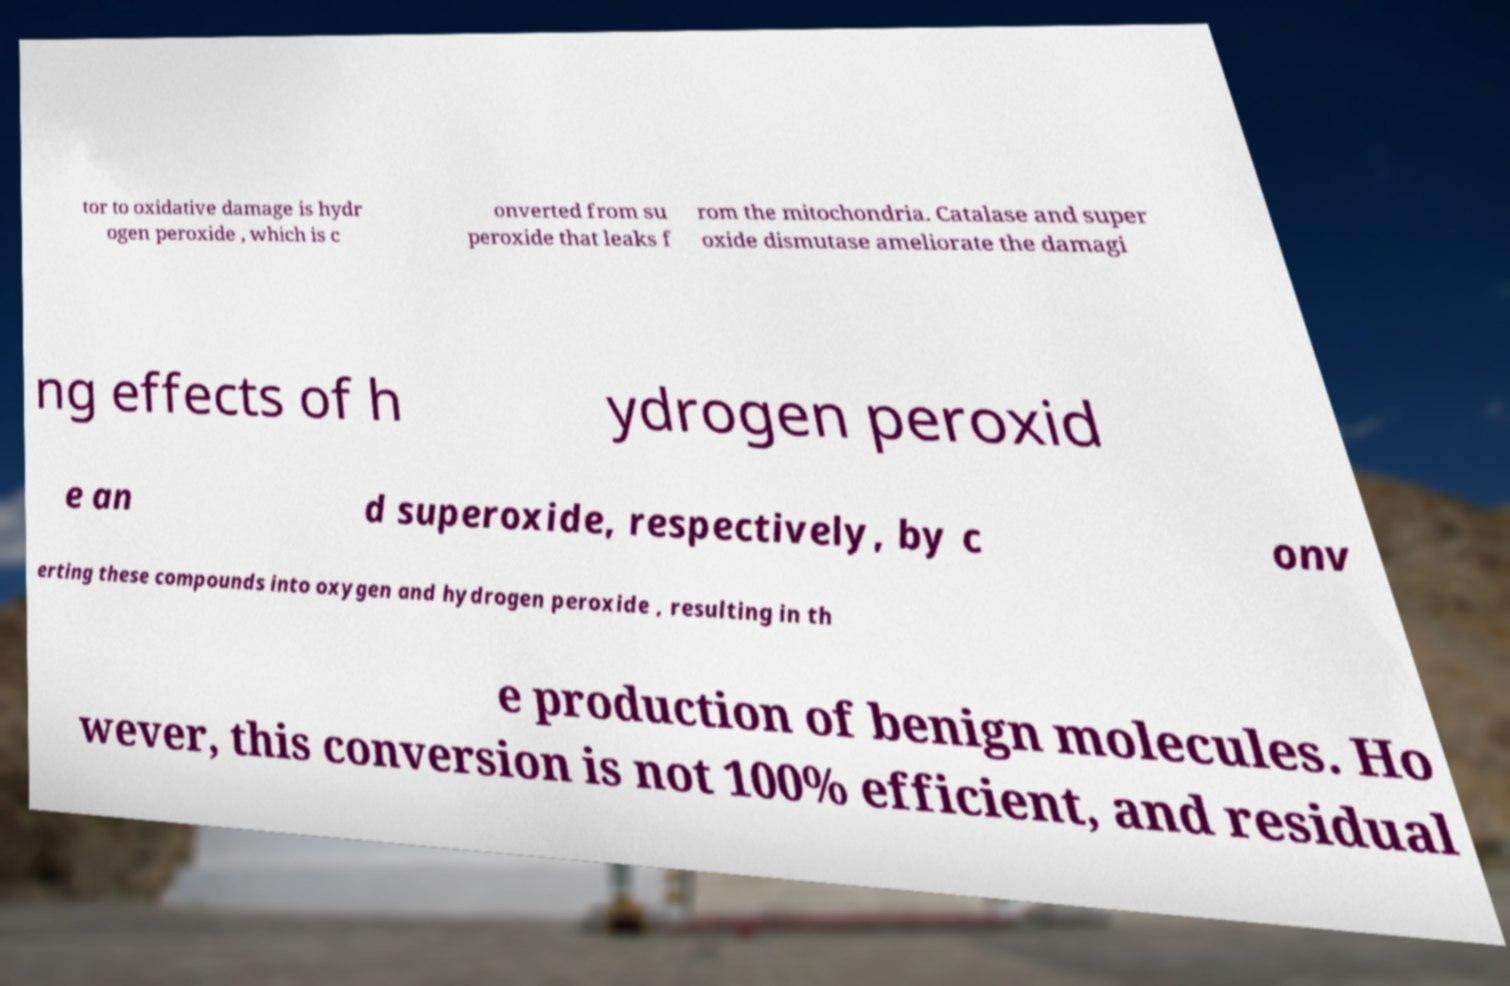Can you accurately transcribe the text from the provided image for me? tor to oxidative damage is hydr ogen peroxide , which is c onverted from su peroxide that leaks f rom the mitochondria. Catalase and super oxide dismutase ameliorate the damagi ng effects of h ydrogen peroxid e an d superoxide, respectively, by c onv erting these compounds into oxygen and hydrogen peroxide , resulting in th e production of benign molecules. Ho wever, this conversion is not 100% efficient, and residual 